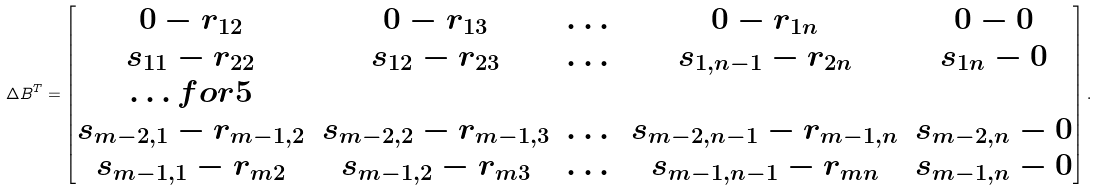Convert formula to latex. <formula><loc_0><loc_0><loc_500><loc_500>\Delta B ^ { T } = \begin{bmatrix} 0 - r _ { 1 2 } & 0 - r _ { 1 3 } & \dots & 0 - r _ { 1 n } & 0 - 0 \\ s _ { 1 1 } - r _ { 2 2 } & s _ { 1 2 } - r _ { 2 3 } & \dots & s _ { 1 , n - 1 } - r _ { 2 n } & s _ { 1 n } - 0 \\ \hdots f o r { 5 } \\ s _ { m - 2 , 1 } - r _ { m - 1 , 2 } & s _ { m - 2 , 2 } - r _ { m - 1 , 3 } & \dots & s _ { m - 2 , n - 1 } - r _ { m - 1 , n } & s _ { m - 2 , n } - 0 \\ s _ { m - 1 , 1 } - r _ { m 2 } & s _ { m - 1 , 2 } - r _ { m 3 } & \dots & s _ { m - 1 , n - 1 } - r _ { m n } & s _ { m - 1 , n } - 0 \end{bmatrix} .</formula> 